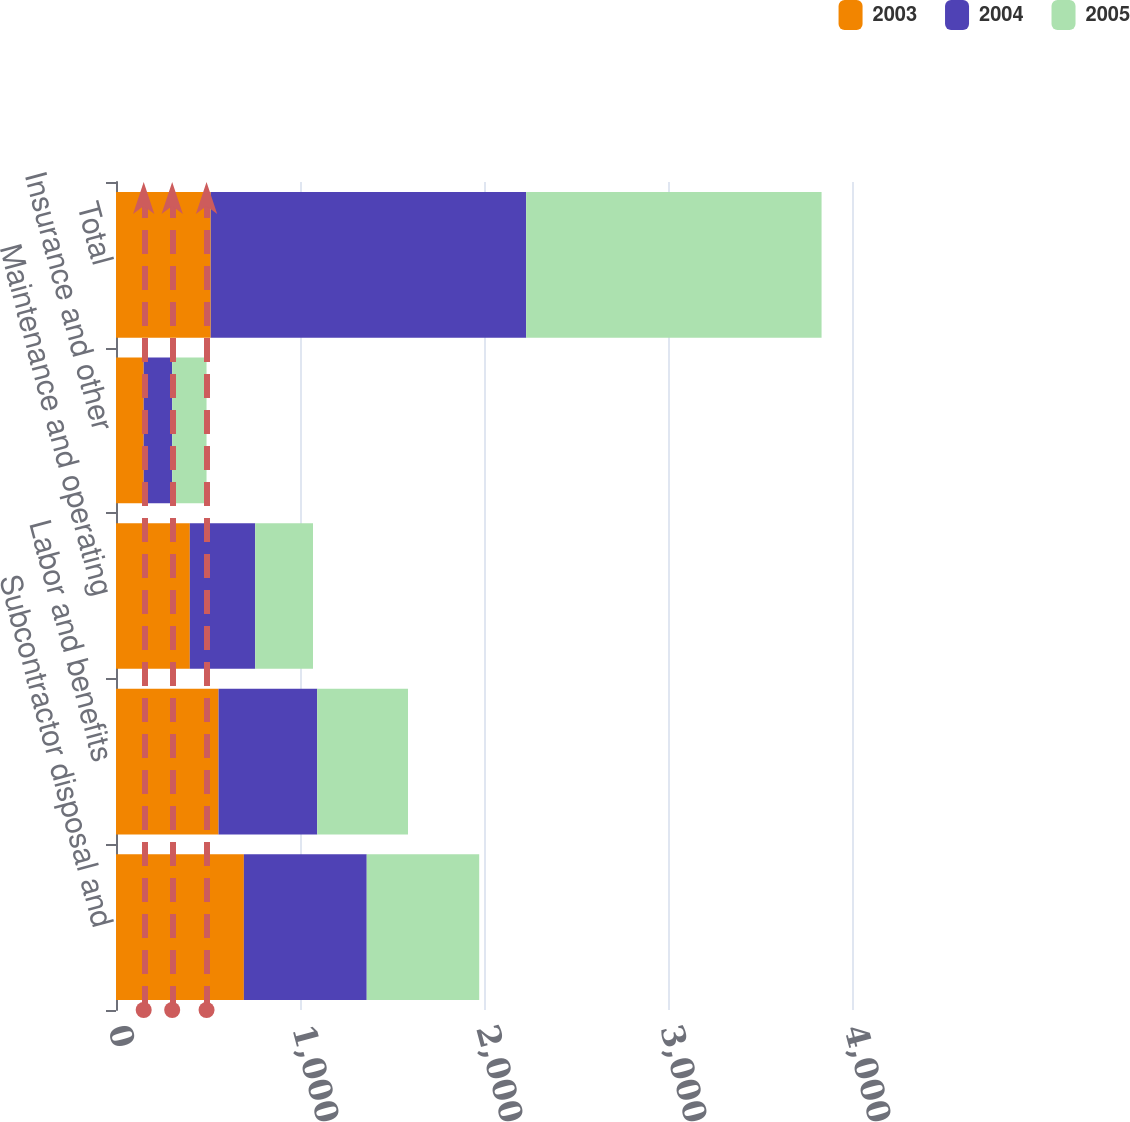Convert chart. <chart><loc_0><loc_0><loc_500><loc_500><stacked_bar_chart><ecel><fcel>Subcontractor disposal and<fcel>Labor and benefits<fcel>Maintenance and operating<fcel>Insurance and other<fcel>Total<nl><fcel>2003<fcel>694.9<fcel>557.3<fcel>401.2<fcel>150.5<fcel>514.8<nl><fcel>2004<fcel>667.8<fcel>536.2<fcel>355.5<fcel>154.9<fcel>1714.4<nl><fcel>2005<fcel>611.3<fcel>493.4<fcel>314<fcel>186.7<fcel>1605.4<nl></chart> 